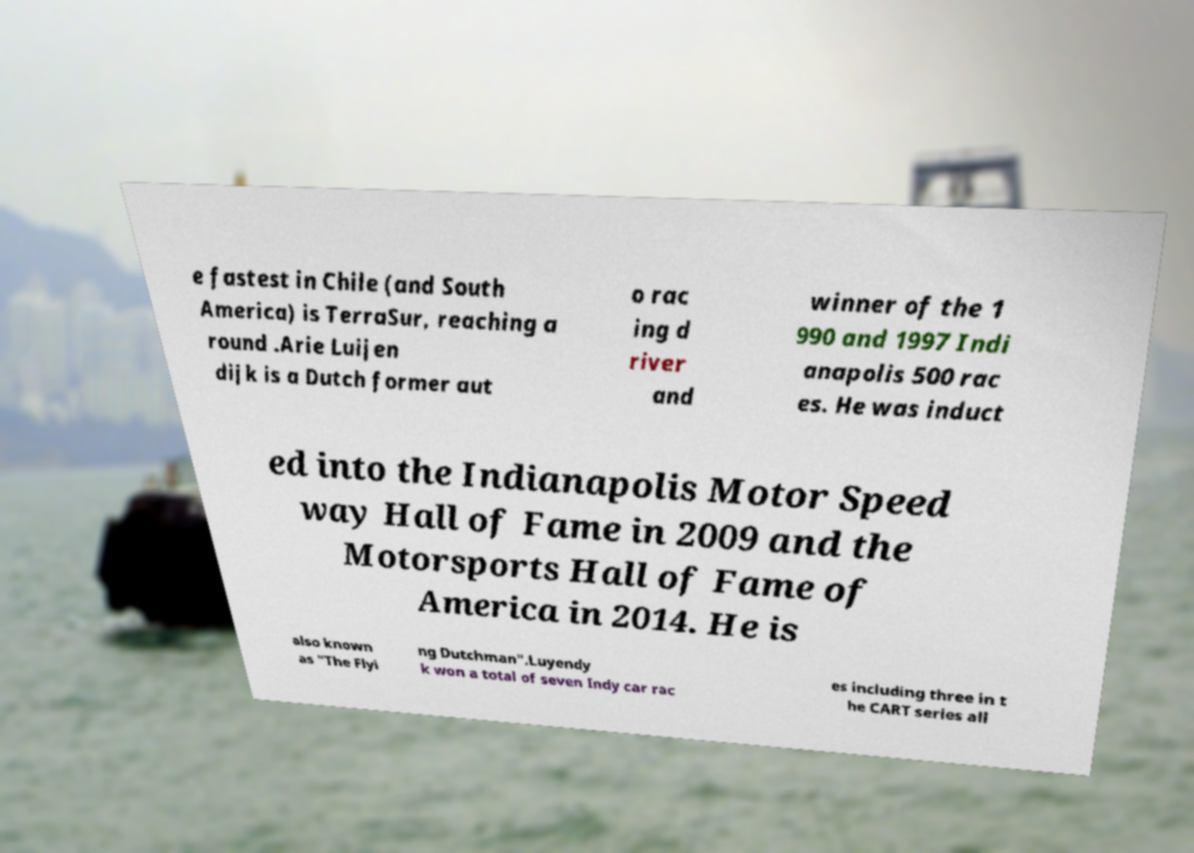Please read and relay the text visible in this image. What does it say? e fastest in Chile (and South America) is TerraSur, reaching a round .Arie Luijen dijk is a Dutch former aut o rac ing d river and winner of the 1 990 and 1997 Indi anapolis 500 rac es. He was induct ed into the Indianapolis Motor Speed way Hall of Fame in 2009 and the Motorsports Hall of Fame of America in 2014. He is also known as "The Flyi ng Dutchman".Luyendy k won a total of seven Indy car rac es including three in t he CART series all 